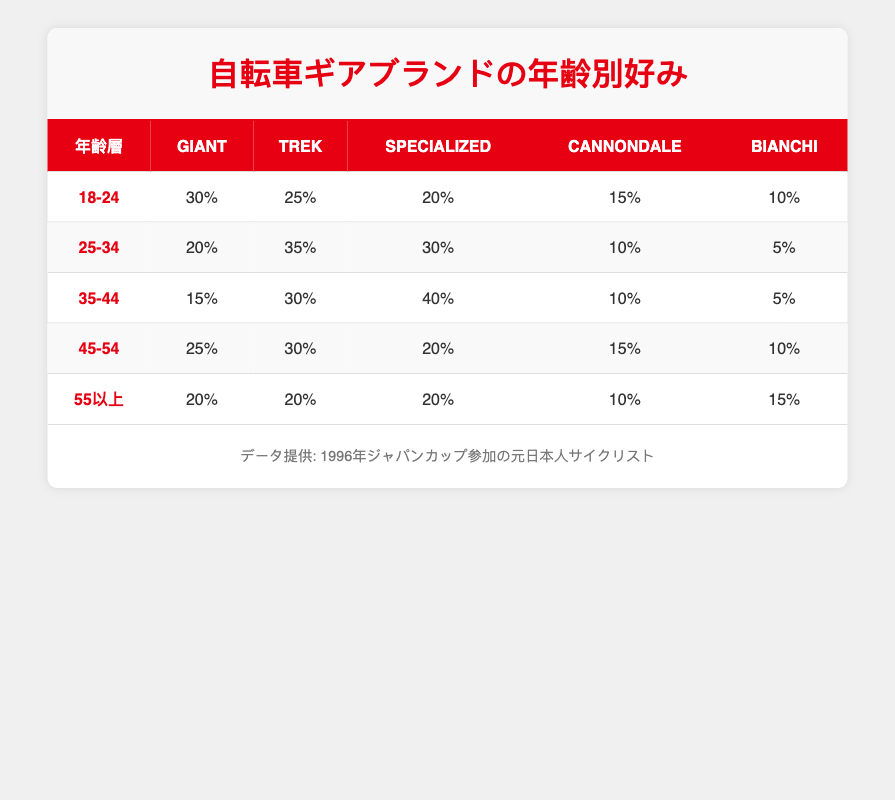What brand is the most preferred among the 25-34 age group? In the 25-34 age group, Trek is the most preferred brand with a preference value of 35%.
Answer: Trek Which age group has the highest preference for Specialized? The age group 35-44 has the highest preference for Specialized, with 40%.
Answer: 35-44 What is the total preference percentage for Giant among all age groups? We can find the total preference for Giant by summing the values from each age group: 30% (18-24) + 20% (25-34) + 15% (35-44) + 25% (45-54) + 20% (55 and older) = 110%.
Answer: 110% Is Cannondale preferred more by the 45-54 age group than by the 55 and older age group? In the 45-54 age group, Cannondale has a preference of 15%, while in the 55 and older group it is 10%. Therefore, Cannondale is more preferred by the 45-54 age group.
Answer: Yes What is the average preference percentage for Bianchi across all age groups? To find the average preference for Bianchi, add its preference values: 10% (18-24) + 5% (25-34) + 5% (35-44) + 10% (45-54) + 15% (55 and older) = 45%. Then, divide by 5 (the number of age groups): 45%/5 = 9%.
Answer: 9% Which brands have equal preference among the 55 and older age group? In the 55 and older age group, Giant, Specialized, and Trek each have a preference of 20%. This indicates that these three brands are equally preferred in this age group.
Answer: Giant, Specialized, Trek If you compare the 18-24 and 45-54 age groups for Trek, which age group has a higher preference? The 18-24 age group has a preference of 25% for Trek, while the 45-54 age group has a preference of 30%. Thus, the 45-54 age group has a higher preference for Trek.
Answer: 45-54 What brand is least preferred among the 25-34 age group? In the 25-34 age group, Bianchi is the least preferred brand with a preference value of 5%.
Answer: Bianchi 